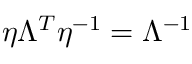Convert formula to latex. <formula><loc_0><loc_0><loc_500><loc_500>\eta \Lambda ^ { T } \eta ^ { - 1 } = \Lambda ^ { - 1 }</formula> 